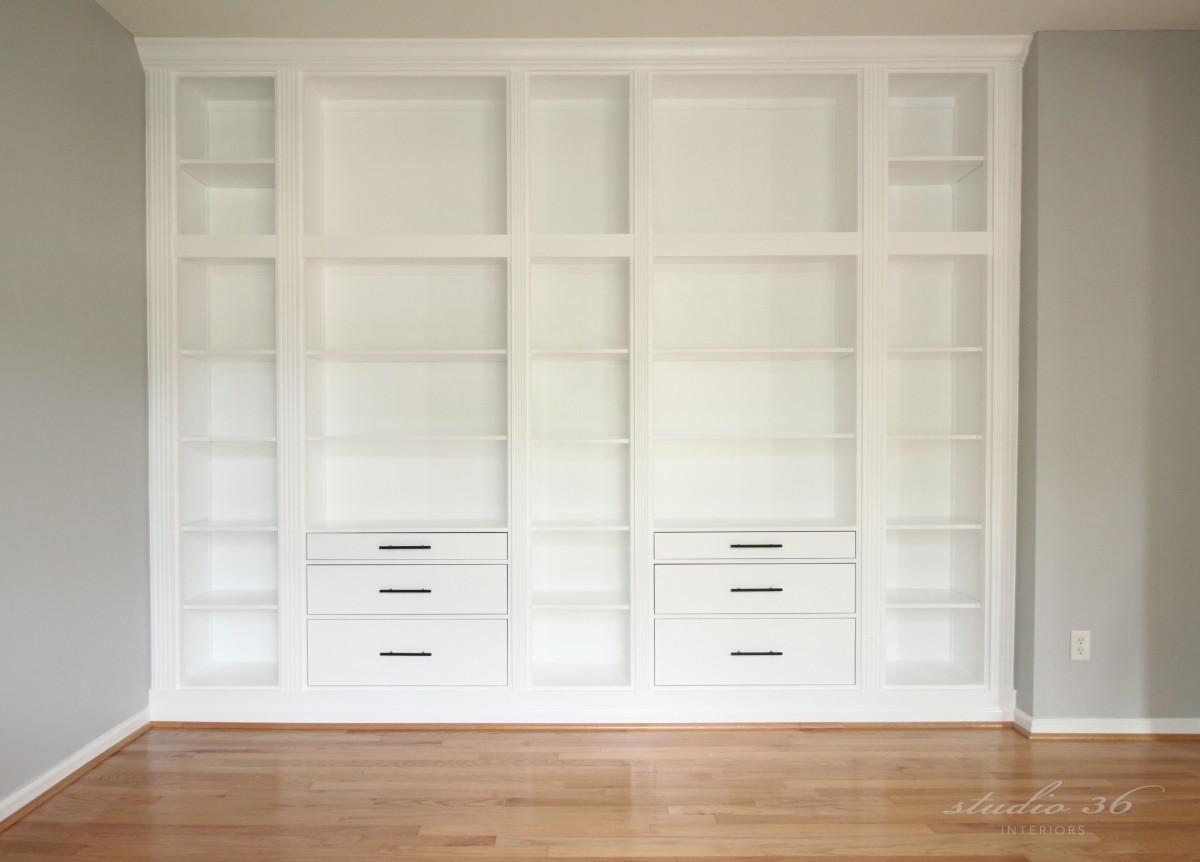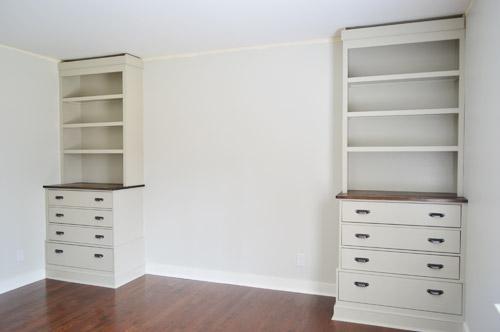The first image is the image on the left, the second image is the image on the right. Evaluate the accuracy of this statement regarding the images: "The left image contains a dark brown bookshelf.". Is it true? Answer yes or no. No. The first image is the image on the left, the second image is the image on the right. Evaluate the accuracy of this statement regarding the images: "In one image, a tall plain boxy bookshelf is a dark walnut color, stands on short legs, and has six shelves, all of them empty.". Is it true? Answer yes or no. No. 